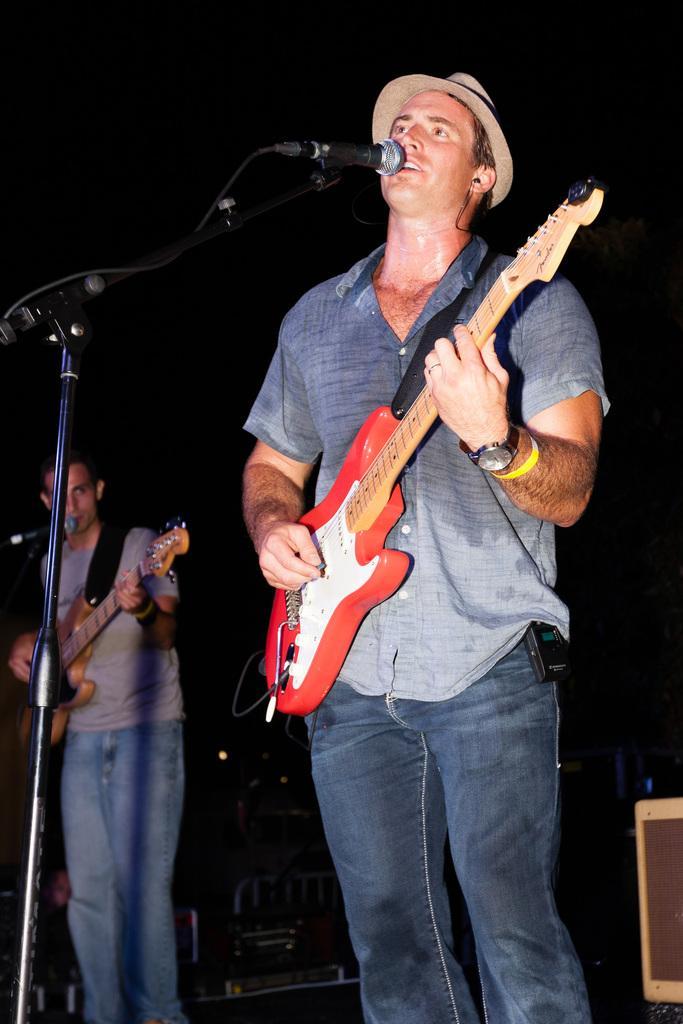Can you describe this image briefly? This image contains two persons standing. Person at the right side is playing guitar. He is wearing watch and cap over his head. Person at the left is wearing a shirt and a pant. There are miles before them. 